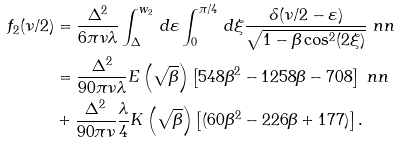Convert formula to latex. <formula><loc_0><loc_0><loc_500><loc_500>f _ { 2 } ( \nu / 2 ) & = \frac { \Delta ^ { 2 } } { 6 \pi \nu \lambda } \int _ { \Delta } ^ { w _ { 2 } } \, d \varepsilon \int _ { 0 } ^ { \pi / 4 } \, d \xi \frac { \delta ( \nu / 2 - \varepsilon ) } { \sqrt { 1 - \beta \cos ^ { 2 } ( 2 \xi ) } } \ n n \\ & = \frac { \Delta ^ { 2 } } { 9 0 \pi \nu \lambda } E \left ( \sqrt { \beta } \right ) \left [ 5 4 8 \beta ^ { 2 } - 1 2 5 8 \beta - 7 0 8 \right ] \ n n \\ & + \frac { \Delta ^ { 2 } } { 9 0 \pi \nu } \frac { \lambda } { 4 } K \left ( \sqrt { \beta } \right ) \left [ ( 6 0 \beta ^ { 2 } - 2 2 6 \beta + 1 7 7 ) \right ] .</formula> 